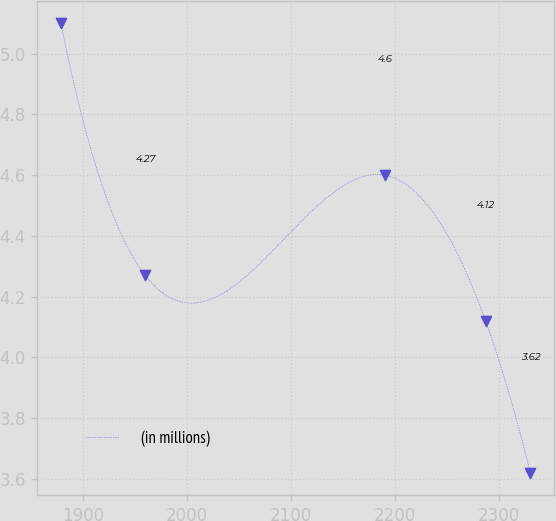<chart> <loc_0><loc_0><loc_500><loc_500><line_chart><ecel><fcel>(in millions)<nl><fcel>1878.93<fcel>5.1<nl><fcel>1959.98<fcel>4.27<nl><fcel>2190.09<fcel>4.6<nl><fcel>2287.04<fcel>4.12<nl><fcel>2330.17<fcel>3.62<nl></chart> 